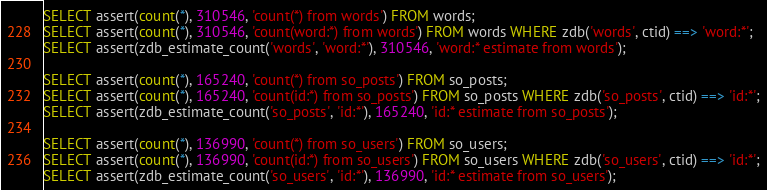Convert code to text. <code><loc_0><loc_0><loc_500><loc_500><_SQL_>SELECT assert(count(*), 310546, 'count(*) from words') FROM words;
SELECT assert(count(*), 310546, 'count(word:*) from words') FROM words WHERE zdb('words', ctid) ==> 'word:*';
SELECT assert(zdb_estimate_count('words', 'word:*'), 310546, 'word:* estimate from words');

SELECT assert(count(*), 165240, 'count(*) from so_posts') FROM so_posts;
SELECT assert(count(*), 165240, 'count(id:*) from so_posts') FROM so_posts WHERE zdb('so_posts', ctid) ==> 'id:*';
SELECT assert(zdb_estimate_count('so_posts', 'id:*'), 165240, 'id:* estimate from so_posts');

SELECT assert(count(*), 136990, 'count(*) from so_users') FROM so_users;
SELECT assert(count(*), 136990, 'count(id:*) from so_users') FROM so_users WHERE zdb('so_users', ctid) ==> 'id:*';
SELECT assert(zdb_estimate_count('so_users', 'id:*'), 136990, 'id:* estimate from so_users');



</code> 